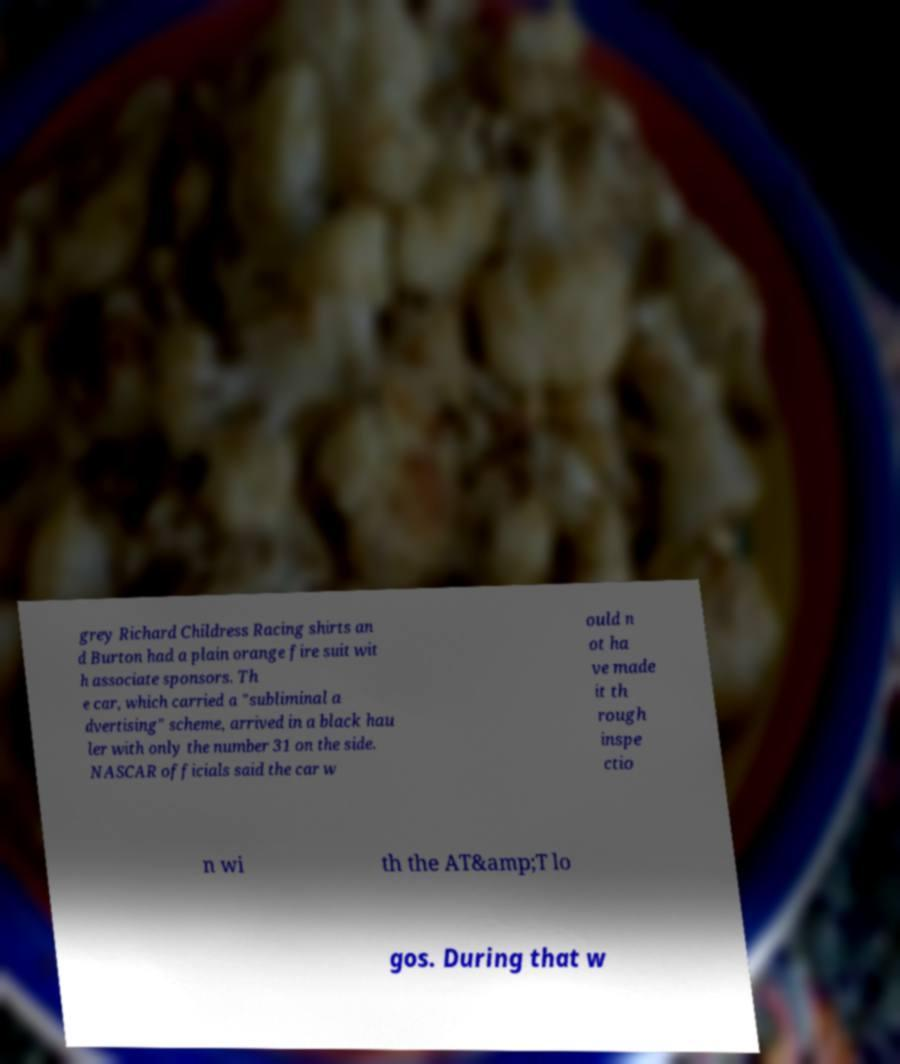Please read and relay the text visible in this image. What does it say? grey Richard Childress Racing shirts an d Burton had a plain orange fire suit wit h associate sponsors. Th e car, which carried a "subliminal a dvertising" scheme, arrived in a black hau ler with only the number 31 on the side. NASCAR officials said the car w ould n ot ha ve made it th rough inspe ctio n wi th the AT&amp;T lo gos. During that w 